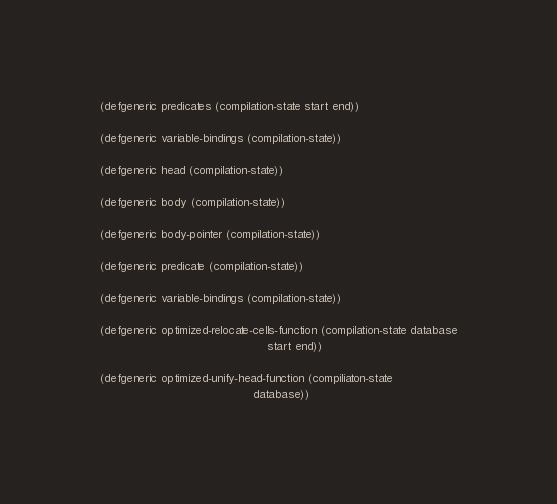<code> <loc_0><loc_0><loc_500><loc_500><_Lisp_>(defgeneric predicates (compilation-state start end))

(defgeneric variable-bindings (compilation-state))

(defgeneric head (compilation-state))

(defgeneric body (compilation-state))

(defgeneric body-pointer (compilation-state))

(defgeneric predicate (compilation-state))

(defgeneric variable-bindings (compilation-state))

(defgeneric optimized-relocate-cells-function (compilation-state database
                                               start end))

(defgeneric optimized-unify-head-function (compiliaton-state
                                           database))
</code> 